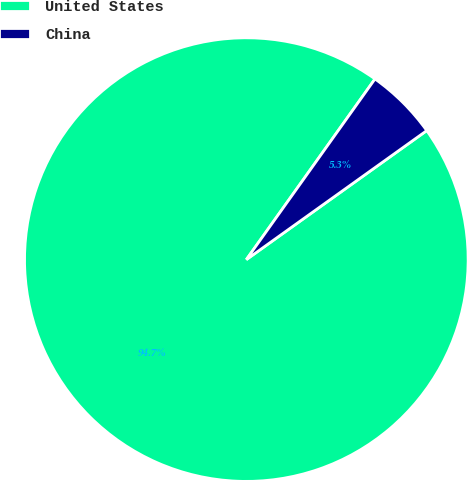Convert chart. <chart><loc_0><loc_0><loc_500><loc_500><pie_chart><fcel>United States<fcel>China<nl><fcel>94.73%<fcel>5.27%<nl></chart> 